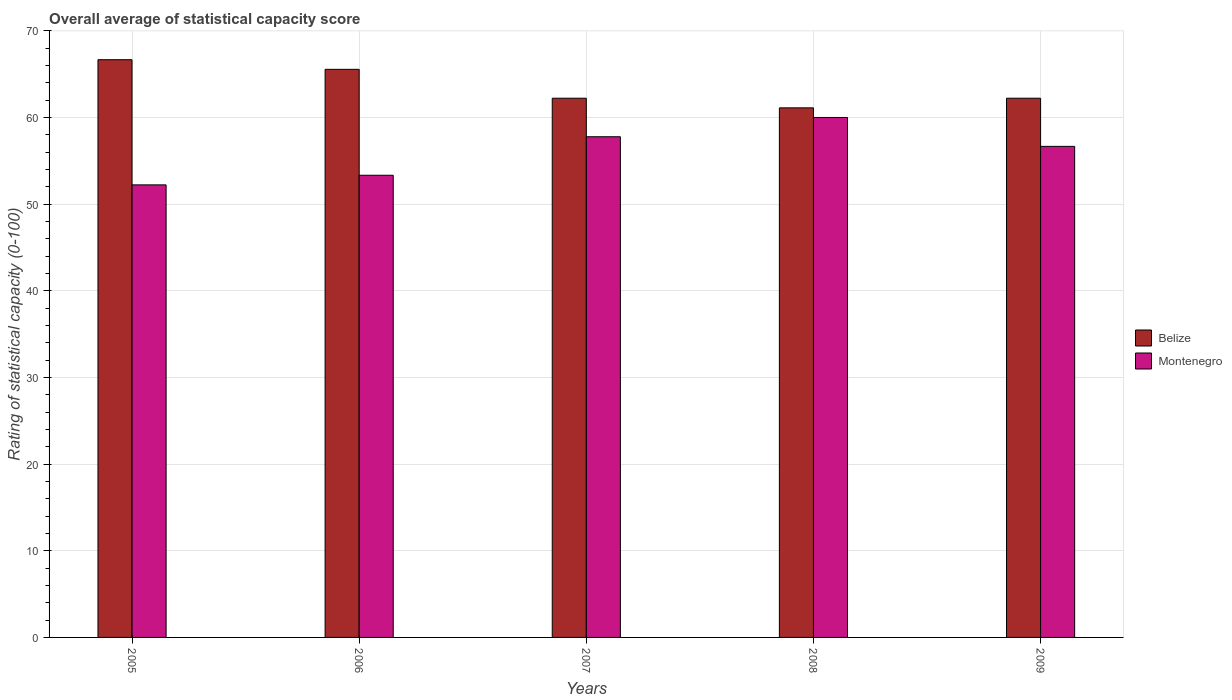How many different coloured bars are there?
Keep it short and to the point. 2. What is the rating of statistical capacity in Montenegro in 2005?
Your answer should be compact. 52.22. Across all years, what is the maximum rating of statistical capacity in Belize?
Ensure brevity in your answer.  66.67. Across all years, what is the minimum rating of statistical capacity in Montenegro?
Make the answer very short. 52.22. What is the total rating of statistical capacity in Montenegro in the graph?
Your response must be concise. 280. What is the difference between the rating of statistical capacity in Montenegro in 2005 and that in 2006?
Make the answer very short. -1.11. What is the difference between the rating of statistical capacity in Belize in 2008 and the rating of statistical capacity in Montenegro in 2009?
Ensure brevity in your answer.  4.44. What is the average rating of statistical capacity in Belize per year?
Give a very brief answer. 63.56. In the year 2008, what is the difference between the rating of statistical capacity in Montenegro and rating of statistical capacity in Belize?
Give a very brief answer. -1.11. In how many years, is the rating of statistical capacity in Belize greater than 12?
Provide a short and direct response. 5. What is the ratio of the rating of statistical capacity in Montenegro in 2006 to that in 2007?
Your answer should be very brief. 0.92. What is the difference between the highest and the second highest rating of statistical capacity in Montenegro?
Offer a terse response. 2.22. What is the difference between the highest and the lowest rating of statistical capacity in Montenegro?
Provide a succinct answer. 7.78. What does the 1st bar from the left in 2009 represents?
Ensure brevity in your answer.  Belize. What does the 1st bar from the right in 2009 represents?
Ensure brevity in your answer.  Montenegro. How many bars are there?
Your answer should be very brief. 10. Are all the bars in the graph horizontal?
Your answer should be compact. No. How many years are there in the graph?
Give a very brief answer. 5. What is the difference between two consecutive major ticks on the Y-axis?
Make the answer very short. 10. Are the values on the major ticks of Y-axis written in scientific E-notation?
Ensure brevity in your answer.  No. Does the graph contain grids?
Offer a terse response. Yes. How many legend labels are there?
Provide a succinct answer. 2. What is the title of the graph?
Ensure brevity in your answer.  Overall average of statistical capacity score. What is the label or title of the Y-axis?
Your answer should be compact. Rating of statistical capacity (0-100). What is the Rating of statistical capacity (0-100) in Belize in 2005?
Your response must be concise. 66.67. What is the Rating of statistical capacity (0-100) in Montenegro in 2005?
Give a very brief answer. 52.22. What is the Rating of statistical capacity (0-100) of Belize in 2006?
Give a very brief answer. 65.56. What is the Rating of statistical capacity (0-100) of Montenegro in 2006?
Your answer should be compact. 53.33. What is the Rating of statistical capacity (0-100) in Belize in 2007?
Your answer should be very brief. 62.22. What is the Rating of statistical capacity (0-100) of Montenegro in 2007?
Give a very brief answer. 57.78. What is the Rating of statistical capacity (0-100) in Belize in 2008?
Offer a terse response. 61.11. What is the Rating of statistical capacity (0-100) of Montenegro in 2008?
Make the answer very short. 60. What is the Rating of statistical capacity (0-100) of Belize in 2009?
Make the answer very short. 62.22. What is the Rating of statistical capacity (0-100) of Montenegro in 2009?
Give a very brief answer. 56.67. Across all years, what is the maximum Rating of statistical capacity (0-100) in Belize?
Your answer should be very brief. 66.67. Across all years, what is the minimum Rating of statistical capacity (0-100) in Belize?
Make the answer very short. 61.11. Across all years, what is the minimum Rating of statistical capacity (0-100) of Montenegro?
Your answer should be compact. 52.22. What is the total Rating of statistical capacity (0-100) of Belize in the graph?
Ensure brevity in your answer.  317.78. What is the total Rating of statistical capacity (0-100) in Montenegro in the graph?
Offer a very short reply. 280. What is the difference between the Rating of statistical capacity (0-100) in Belize in 2005 and that in 2006?
Your answer should be very brief. 1.11. What is the difference between the Rating of statistical capacity (0-100) of Montenegro in 2005 and that in 2006?
Your response must be concise. -1.11. What is the difference between the Rating of statistical capacity (0-100) of Belize in 2005 and that in 2007?
Provide a short and direct response. 4.44. What is the difference between the Rating of statistical capacity (0-100) in Montenegro in 2005 and that in 2007?
Keep it short and to the point. -5.55. What is the difference between the Rating of statistical capacity (0-100) in Belize in 2005 and that in 2008?
Give a very brief answer. 5.56. What is the difference between the Rating of statistical capacity (0-100) of Montenegro in 2005 and that in 2008?
Your answer should be very brief. -7.78. What is the difference between the Rating of statistical capacity (0-100) of Belize in 2005 and that in 2009?
Offer a terse response. 4.44. What is the difference between the Rating of statistical capacity (0-100) in Montenegro in 2005 and that in 2009?
Offer a terse response. -4.44. What is the difference between the Rating of statistical capacity (0-100) of Montenegro in 2006 and that in 2007?
Provide a succinct answer. -4.44. What is the difference between the Rating of statistical capacity (0-100) in Belize in 2006 and that in 2008?
Offer a very short reply. 4.44. What is the difference between the Rating of statistical capacity (0-100) of Montenegro in 2006 and that in 2008?
Your answer should be compact. -6.67. What is the difference between the Rating of statistical capacity (0-100) of Montenegro in 2007 and that in 2008?
Give a very brief answer. -2.22. What is the difference between the Rating of statistical capacity (0-100) in Montenegro in 2007 and that in 2009?
Give a very brief answer. 1.11. What is the difference between the Rating of statistical capacity (0-100) in Belize in 2008 and that in 2009?
Your answer should be very brief. -1.11. What is the difference between the Rating of statistical capacity (0-100) in Belize in 2005 and the Rating of statistical capacity (0-100) in Montenegro in 2006?
Offer a very short reply. 13.33. What is the difference between the Rating of statistical capacity (0-100) of Belize in 2005 and the Rating of statistical capacity (0-100) of Montenegro in 2007?
Provide a short and direct response. 8.89. What is the difference between the Rating of statistical capacity (0-100) in Belize in 2005 and the Rating of statistical capacity (0-100) in Montenegro in 2008?
Keep it short and to the point. 6.67. What is the difference between the Rating of statistical capacity (0-100) of Belize in 2006 and the Rating of statistical capacity (0-100) of Montenegro in 2007?
Your answer should be compact. 7.78. What is the difference between the Rating of statistical capacity (0-100) in Belize in 2006 and the Rating of statistical capacity (0-100) in Montenegro in 2008?
Your answer should be very brief. 5.56. What is the difference between the Rating of statistical capacity (0-100) of Belize in 2006 and the Rating of statistical capacity (0-100) of Montenegro in 2009?
Your answer should be compact. 8.89. What is the difference between the Rating of statistical capacity (0-100) of Belize in 2007 and the Rating of statistical capacity (0-100) of Montenegro in 2008?
Keep it short and to the point. 2.22. What is the difference between the Rating of statistical capacity (0-100) in Belize in 2007 and the Rating of statistical capacity (0-100) in Montenegro in 2009?
Your answer should be very brief. 5.56. What is the difference between the Rating of statistical capacity (0-100) in Belize in 2008 and the Rating of statistical capacity (0-100) in Montenegro in 2009?
Ensure brevity in your answer.  4.44. What is the average Rating of statistical capacity (0-100) of Belize per year?
Offer a very short reply. 63.56. What is the average Rating of statistical capacity (0-100) of Montenegro per year?
Your answer should be compact. 56. In the year 2005, what is the difference between the Rating of statistical capacity (0-100) in Belize and Rating of statistical capacity (0-100) in Montenegro?
Your answer should be compact. 14.44. In the year 2006, what is the difference between the Rating of statistical capacity (0-100) of Belize and Rating of statistical capacity (0-100) of Montenegro?
Offer a terse response. 12.22. In the year 2007, what is the difference between the Rating of statistical capacity (0-100) of Belize and Rating of statistical capacity (0-100) of Montenegro?
Provide a succinct answer. 4.44. In the year 2008, what is the difference between the Rating of statistical capacity (0-100) in Belize and Rating of statistical capacity (0-100) in Montenegro?
Provide a short and direct response. 1.11. In the year 2009, what is the difference between the Rating of statistical capacity (0-100) of Belize and Rating of statistical capacity (0-100) of Montenegro?
Provide a succinct answer. 5.56. What is the ratio of the Rating of statistical capacity (0-100) in Belize in 2005 to that in 2006?
Your answer should be very brief. 1.02. What is the ratio of the Rating of statistical capacity (0-100) of Montenegro in 2005 to that in 2006?
Provide a short and direct response. 0.98. What is the ratio of the Rating of statistical capacity (0-100) of Belize in 2005 to that in 2007?
Ensure brevity in your answer.  1.07. What is the ratio of the Rating of statistical capacity (0-100) of Montenegro in 2005 to that in 2007?
Keep it short and to the point. 0.9. What is the ratio of the Rating of statistical capacity (0-100) in Montenegro in 2005 to that in 2008?
Your response must be concise. 0.87. What is the ratio of the Rating of statistical capacity (0-100) of Belize in 2005 to that in 2009?
Provide a short and direct response. 1.07. What is the ratio of the Rating of statistical capacity (0-100) of Montenegro in 2005 to that in 2009?
Make the answer very short. 0.92. What is the ratio of the Rating of statistical capacity (0-100) of Belize in 2006 to that in 2007?
Keep it short and to the point. 1.05. What is the ratio of the Rating of statistical capacity (0-100) in Montenegro in 2006 to that in 2007?
Provide a succinct answer. 0.92. What is the ratio of the Rating of statistical capacity (0-100) of Belize in 2006 to that in 2008?
Ensure brevity in your answer.  1.07. What is the ratio of the Rating of statistical capacity (0-100) in Belize in 2006 to that in 2009?
Offer a very short reply. 1.05. What is the ratio of the Rating of statistical capacity (0-100) in Belize in 2007 to that in 2008?
Offer a very short reply. 1.02. What is the ratio of the Rating of statistical capacity (0-100) of Montenegro in 2007 to that in 2009?
Give a very brief answer. 1.02. What is the ratio of the Rating of statistical capacity (0-100) in Belize in 2008 to that in 2009?
Your answer should be compact. 0.98. What is the ratio of the Rating of statistical capacity (0-100) in Montenegro in 2008 to that in 2009?
Offer a very short reply. 1.06. What is the difference between the highest and the second highest Rating of statistical capacity (0-100) in Montenegro?
Offer a terse response. 2.22. What is the difference between the highest and the lowest Rating of statistical capacity (0-100) of Belize?
Give a very brief answer. 5.56. What is the difference between the highest and the lowest Rating of statistical capacity (0-100) in Montenegro?
Make the answer very short. 7.78. 